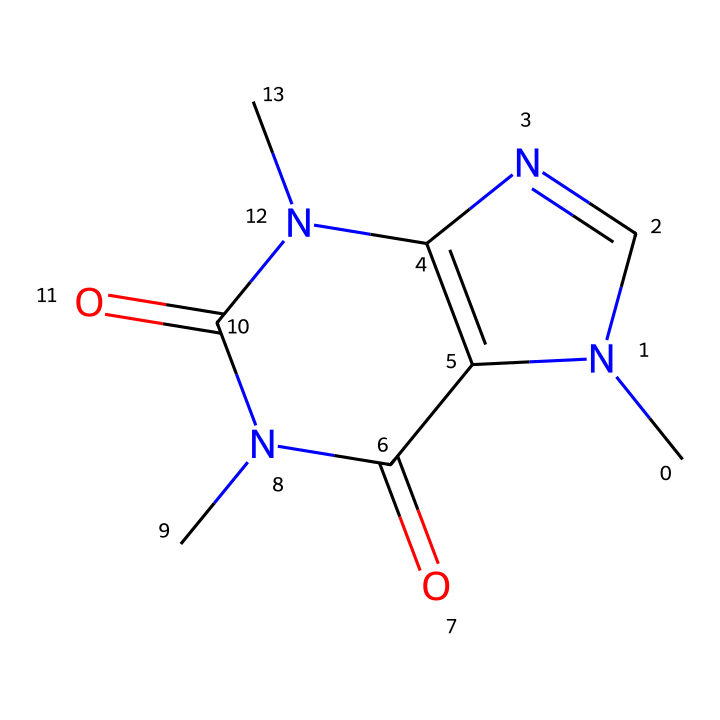What is the molecular formula of caffeine? By counting the atoms in the SMILES representation, we have C=carbon, N=nitrogen, and O=oxygen atoms. Specifically, there are 8 carbon atoms, 10 hydrogen atoms, 4 nitrogen atoms, and 2 oxygen atoms, leading to the molecular formula C8H10N4O2.
Answer: C8H10N4O2 How many ring structures are present in caffeine? Analyzing the structure depicted in the SMILES shows that caffeine contains two rings formed by carbon and nitrogen atoms. Each ring must connect back to itself and connect through atoms, confirming that there are two rings.
Answer: 2 What type of chemical is caffeine considered? Caffeine belongs to the category of cycloalkaloids, which encompass compounds formed in cyclic structures with nitrogen-containing components. The rings and nitrogen atom placement indicate its classification.
Answer: cycloalkaloid What is the total number of nitrogen atoms in caffeine? The SMILES representation shows four nitrogen atoms in total. By identifying the 'N' indicators in the structure, you count them to get the total.
Answer: 4 Which part of the caffeine structure contributes to its stimulant effect? The presence of nitrogen atoms in cyclic structures, specifically the amino groups, plays a significant role in the stimulant effects of caffeine as they influence interactions with neuroreceptors.
Answer: nitrogen atoms Does caffeine have any double bonds in its structure? Examination of the SMILES structure indicates the presence of double bonds, particularly where the carbon atoms connect to oxygen atoms and nitrogen atoms. The depiction features double bonds that can be seen in the chemical structure.
Answer: yes 